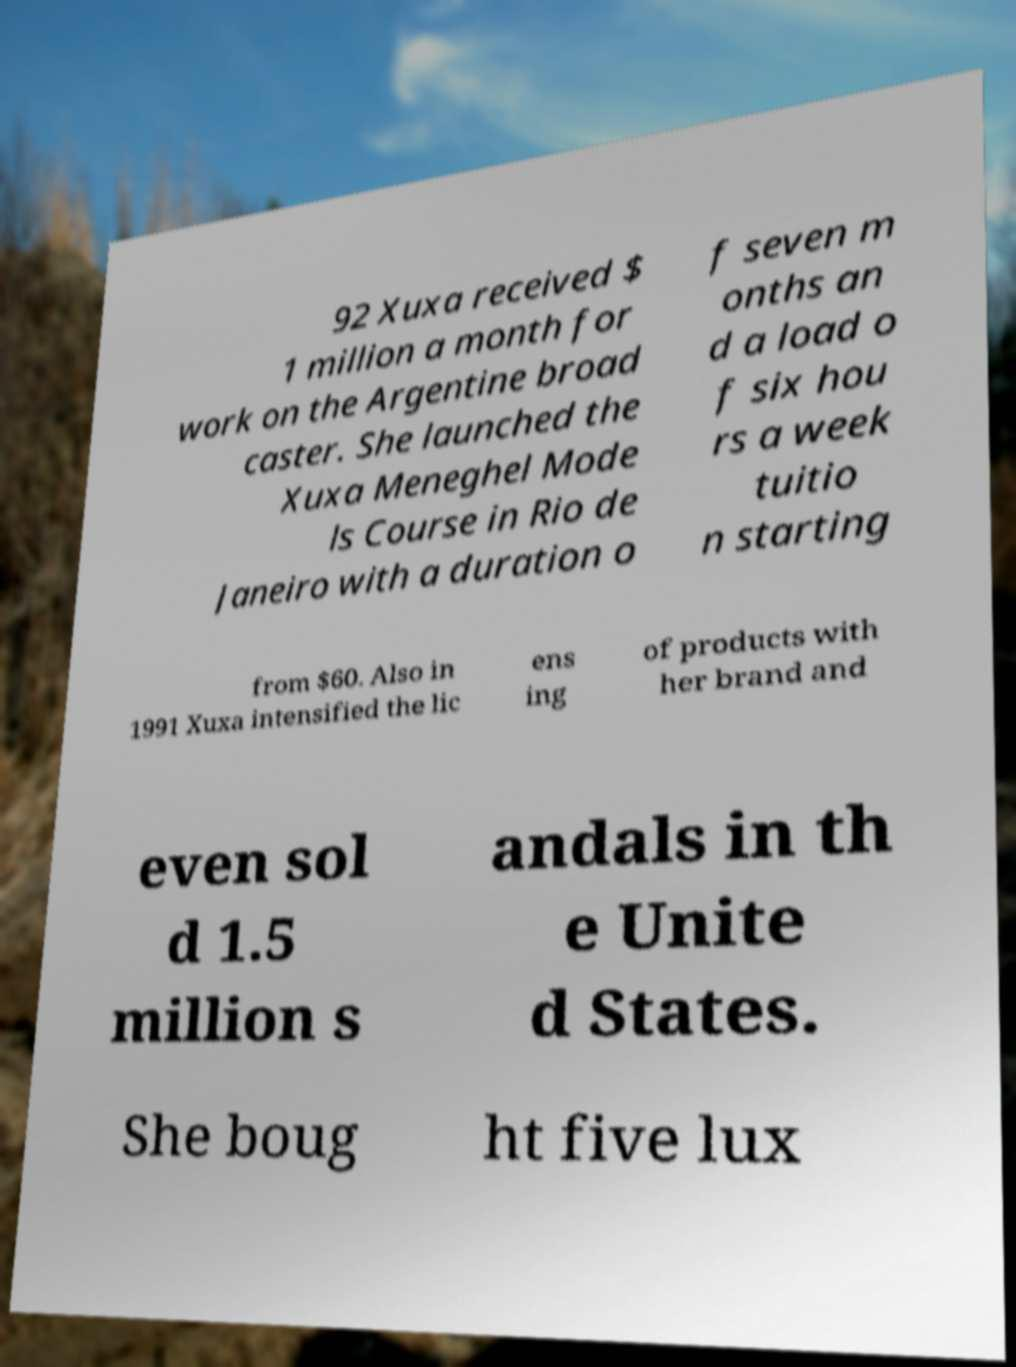I need the written content from this picture converted into text. Can you do that? 92 Xuxa received $ 1 million a month for work on the Argentine broad caster. She launched the Xuxa Meneghel Mode ls Course in Rio de Janeiro with a duration o f seven m onths an d a load o f six hou rs a week tuitio n starting from $60. Also in 1991 Xuxa intensified the lic ens ing of products with her brand and even sol d 1.5 million s andals in th e Unite d States. She boug ht five lux 